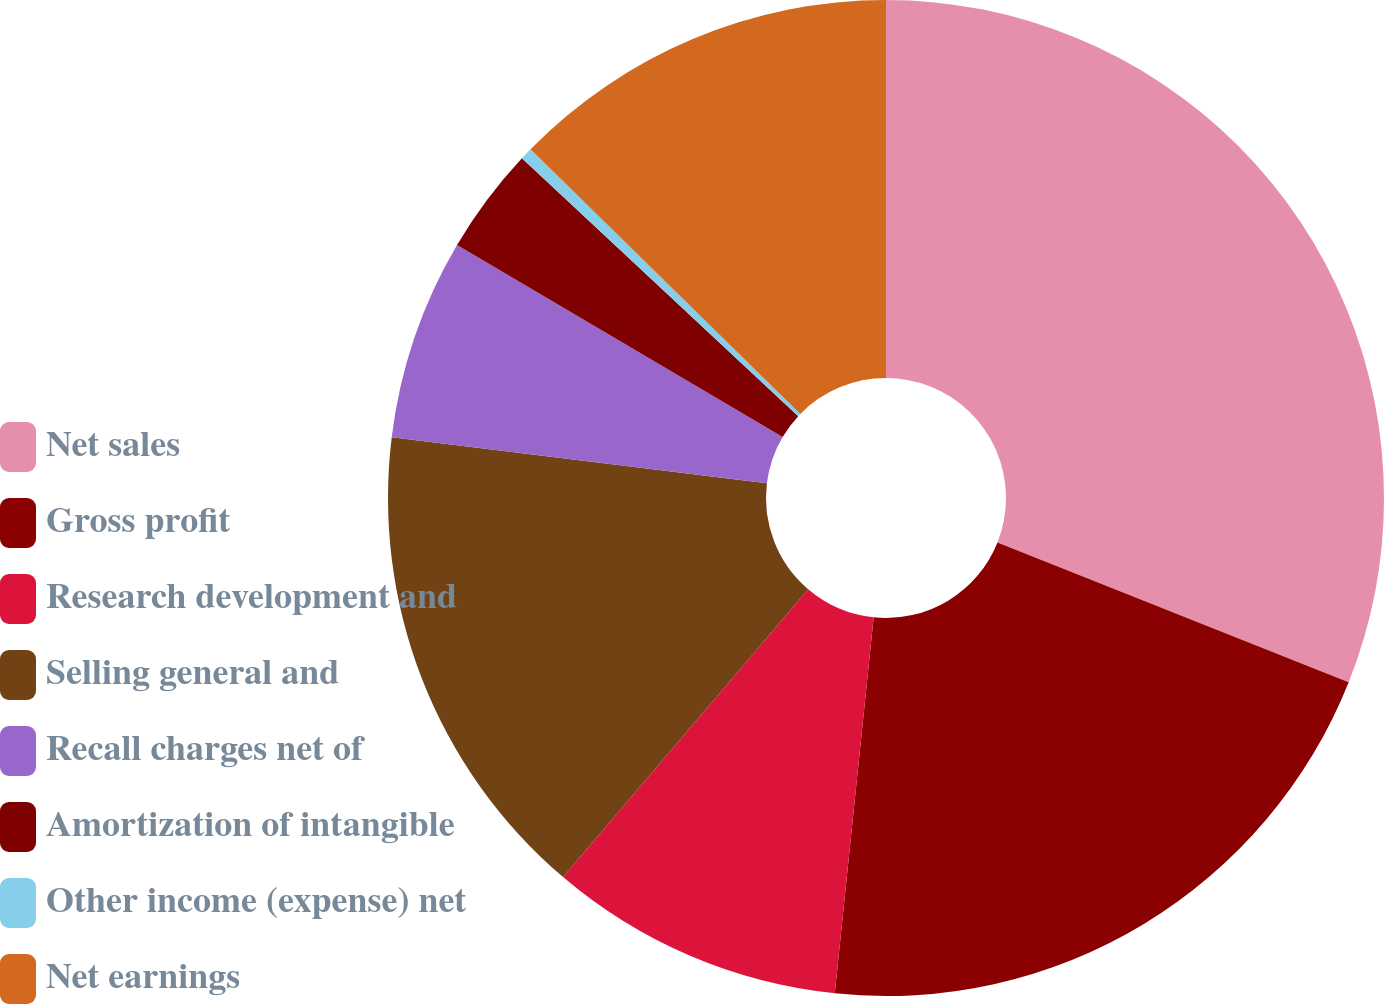Convert chart to OTSL. <chart><loc_0><loc_0><loc_500><loc_500><pie_chart><fcel>Net sales<fcel>Gross profit<fcel>Research development and<fcel>Selling general and<fcel>Recall charges net of<fcel>Amortization of intangible<fcel>Other income (expense) net<fcel>Net earnings<nl><fcel>31.03%<fcel>20.61%<fcel>9.59%<fcel>15.72%<fcel>6.53%<fcel>3.47%<fcel>0.4%<fcel>12.65%<nl></chart> 